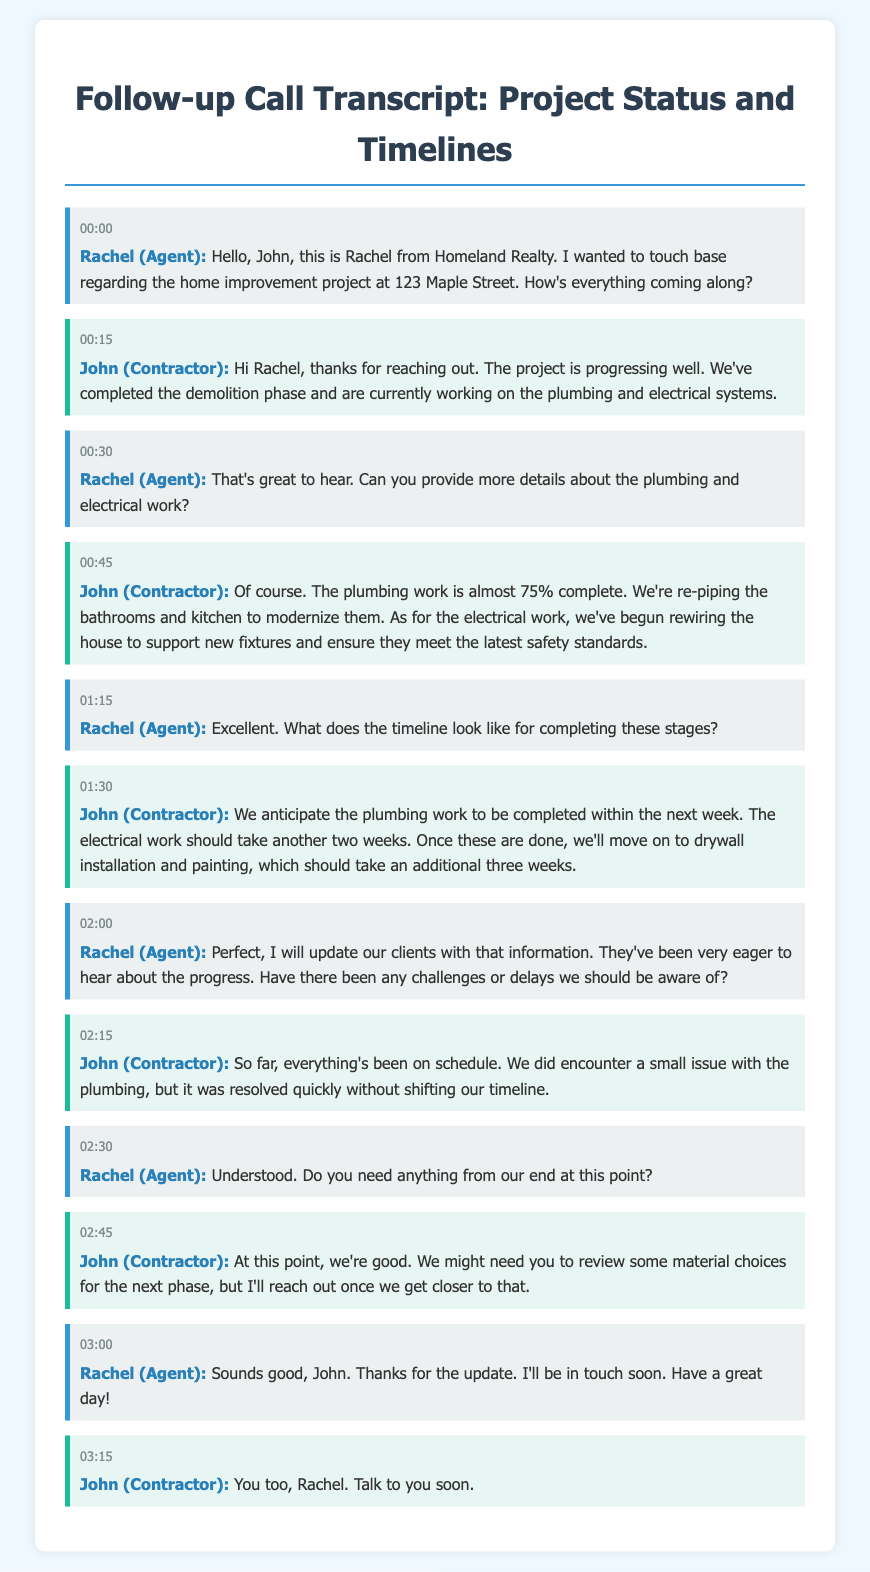What is the address of the project? The address of the home improvement project mentioned in the document is 123 Maple Street.
Answer: 123 Maple Street Who is the contractor? The contractor involved in the project is John.
Answer: John What percentage of the plumbing work is complete? It is mentioned that the plumbing work is almost 75% complete.
Answer: 75% How long until the plumbing work is expected to be finished? The contractor states that the plumbing work is anticipated to be completed within the next week.
Answer: Next week What will happen after the plumbing and electrical work are completed? After these works, the contractor will move on to drywall installation and painting.
Answer: Drywall installation and painting What issue was encountered during the plumbing work? The document indicates that a small issue with the plumbing was encountered.
Answer: A small issue What does Rachel need to review for the next phase? Rachel may need to review some material choices for the next phase of the project.
Answer: Material choices How long will the electrical work take? The contractor mentioned that the electrical work should take another two weeks to complete.
Answer: Two weeks What is the main concern Rachel addresses in the call? Rachel is concerned about the progress of the home improvement project and any challenges or delays.
Answer: Progress and challenges 